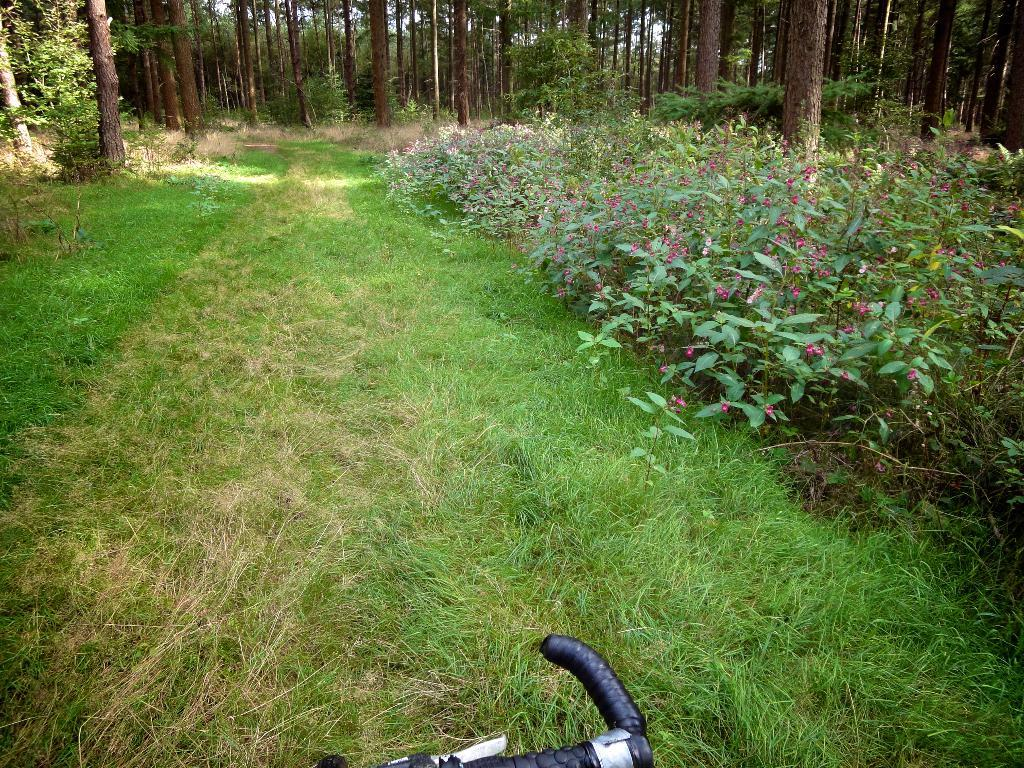What type of vegetation can be seen in the image? There is grass and plants visible in the image. What can be seen in the background of the image? There are trees visible in the background of the image. Can you see a monkey climbing one of the trees in the image? There is no monkey present in the image; it only features grass, plants, and trees. 